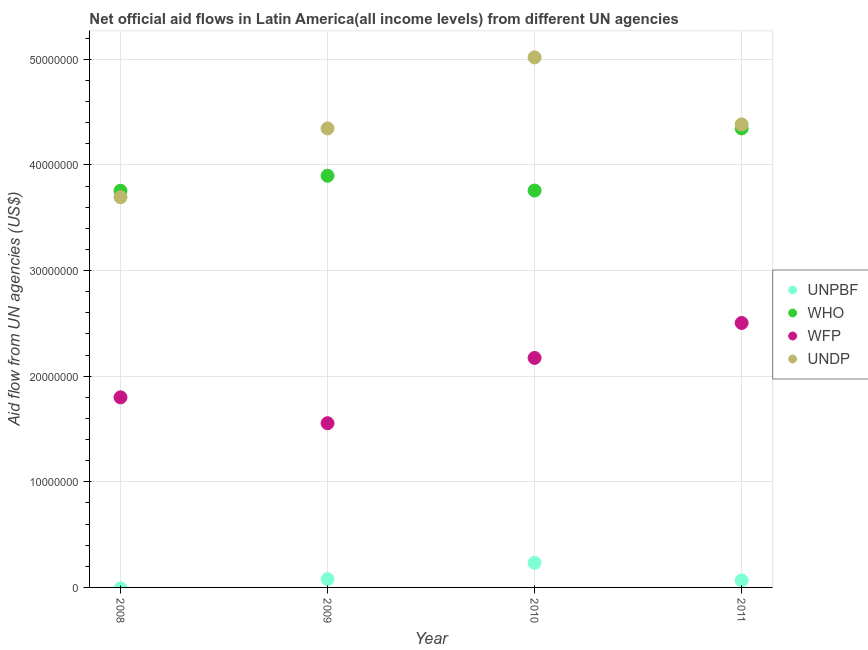How many different coloured dotlines are there?
Provide a succinct answer. 4. Is the number of dotlines equal to the number of legend labels?
Offer a very short reply. No. What is the amount of aid given by who in 2008?
Ensure brevity in your answer.  3.76e+07. Across all years, what is the maximum amount of aid given by unpbf?
Keep it short and to the point. 2.33e+06. Across all years, what is the minimum amount of aid given by undp?
Offer a terse response. 3.70e+07. What is the total amount of aid given by who in the graph?
Your response must be concise. 1.58e+08. What is the difference between the amount of aid given by undp in 2008 and that in 2009?
Provide a succinct answer. -6.51e+06. What is the difference between the amount of aid given by wfp in 2010 and the amount of aid given by undp in 2009?
Offer a terse response. -2.17e+07. What is the average amount of aid given by who per year?
Your response must be concise. 3.94e+07. In the year 2009, what is the difference between the amount of aid given by who and amount of aid given by wfp?
Provide a short and direct response. 2.34e+07. What is the ratio of the amount of aid given by who in 2008 to that in 2010?
Keep it short and to the point. 1. Is the difference between the amount of aid given by wfp in 2010 and 2011 greater than the difference between the amount of aid given by undp in 2010 and 2011?
Your answer should be compact. No. What is the difference between the highest and the second highest amount of aid given by wfp?
Your answer should be very brief. 3.31e+06. What is the difference between the highest and the lowest amount of aid given by undp?
Offer a very short reply. 1.32e+07. Is the sum of the amount of aid given by wfp in 2008 and 2010 greater than the maximum amount of aid given by who across all years?
Provide a succinct answer. No. Is it the case that in every year, the sum of the amount of aid given by unpbf and amount of aid given by who is greater than the sum of amount of aid given by undp and amount of aid given by wfp?
Offer a terse response. No. Is the amount of aid given by wfp strictly less than the amount of aid given by unpbf over the years?
Offer a terse response. No. How many dotlines are there?
Ensure brevity in your answer.  4. What is the difference between two consecutive major ticks on the Y-axis?
Your answer should be very brief. 1.00e+07. Does the graph contain any zero values?
Provide a short and direct response. Yes. Does the graph contain grids?
Ensure brevity in your answer.  Yes. How are the legend labels stacked?
Keep it short and to the point. Vertical. What is the title of the graph?
Provide a succinct answer. Net official aid flows in Latin America(all income levels) from different UN agencies. Does "Fiscal policy" appear as one of the legend labels in the graph?
Offer a very short reply. No. What is the label or title of the Y-axis?
Give a very brief answer. Aid flow from UN agencies (US$). What is the Aid flow from UN agencies (US$) in UNPBF in 2008?
Offer a terse response. 0. What is the Aid flow from UN agencies (US$) in WHO in 2008?
Your answer should be compact. 3.76e+07. What is the Aid flow from UN agencies (US$) in WFP in 2008?
Make the answer very short. 1.80e+07. What is the Aid flow from UN agencies (US$) of UNDP in 2008?
Offer a terse response. 3.70e+07. What is the Aid flow from UN agencies (US$) of UNPBF in 2009?
Your response must be concise. 7.90e+05. What is the Aid flow from UN agencies (US$) of WHO in 2009?
Provide a succinct answer. 3.90e+07. What is the Aid flow from UN agencies (US$) in WFP in 2009?
Keep it short and to the point. 1.56e+07. What is the Aid flow from UN agencies (US$) in UNDP in 2009?
Offer a terse response. 4.35e+07. What is the Aid flow from UN agencies (US$) of UNPBF in 2010?
Your response must be concise. 2.33e+06. What is the Aid flow from UN agencies (US$) of WHO in 2010?
Provide a succinct answer. 3.76e+07. What is the Aid flow from UN agencies (US$) in WFP in 2010?
Provide a short and direct response. 2.17e+07. What is the Aid flow from UN agencies (US$) in UNDP in 2010?
Your answer should be very brief. 5.02e+07. What is the Aid flow from UN agencies (US$) in UNPBF in 2011?
Give a very brief answer. 6.70e+05. What is the Aid flow from UN agencies (US$) of WHO in 2011?
Provide a short and direct response. 4.35e+07. What is the Aid flow from UN agencies (US$) in WFP in 2011?
Provide a succinct answer. 2.50e+07. What is the Aid flow from UN agencies (US$) of UNDP in 2011?
Give a very brief answer. 4.38e+07. Across all years, what is the maximum Aid flow from UN agencies (US$) in UNPBF?
Provide a succinct answer. 2.33e+06. Across all years, what is the maximum Aid flow from UN agencies (US$) in WHO?
Ensure brevity in your answer.  4.35e+07. Across all years, what is the maximum Aid flow from UN agencies (US$) of WFP?
Your answer should be compact. 2.50e+07. Across all years, what is the maximum Aid flow from UN agencies (US$) of UNDP?
Give a very brief answer. 5.02e+07. Across all years, what is the minimum Aid flow from UN agencies (US$) of UNPBF?
Offer a very short reply. 0. Across all years, what is the minimum Aid flow from UN agencies (US$) in WHO?
Offer a very short reply. 3.76e+07. Across all years, what is the minimum Aid flow from UN agencies (US$) in WFP?
Provide a short and direct response. 1.56e+07. Across all years, what is the minimum Aid flow from UN agencies (US$) in UNDP?
Keep it short and to the point. 3.70e+07. What is the total Aid flow from UN agencies (US$) of UNPBF in the graph?
Offer a terse response. 3.79e+06. What is the total Aid flow from UN agencies (US$) of WHO in the graph?
Ensure brevity in your answer.  1.58e+08. What is the total Aid flow from UN agencies (US$) in WFP in the graph?
Provide a short and direct response. 8.03e+07. What is the total Aid flow from UN agencies (US$) in UNDP in the graph?
Provide a succinct answer. 1.74e+08. What is the difference between the Aid flow from UN agencies (US$) in WHO in 2008 and that in 2009?
Provide a short and direct response. -1.42e+06. What is the difference between the Aid flow from UN agencies (US$) of WFP in 2008 and that in 2009?
Your answer should be compact. 2.45e+06. What is the difference between the Aid flow from UN agencies (US$) of UNDP in 2008 and that in 2009?
Give a very brief answer. -6.51e+06. What is the difference between the Aid flow from UN agencies (US$) of WFP in 2008 and that in 2010?
Ensure brevity in your answer.  -3.73e+06. What is the difference between the Aid flow from UN agencies (US$) in UNDP in 2008 and that in 2010?
Offer a very short reply. -1.32e+07. What is the difference between the Aid flow from UN agencies (US$) in WHO in 2008 and that in 2011?
Make the answer very short. -5.90e+06. What is the difference between the Aid flow from UN agencies (US$) in WFP in 2008 and that in 2011?
Keep it short and to the point. -7.04e+06. What is the difference between the Aid flow from UN agencies (US$) of UNDP in 2008 and that in 2011?
Provide a short and direct response. -6.89e+06. What is the difference between the Aid flow from UN agencies (US$) of UNPBF in 2009 and that in 2010?
Ensure brevity in your answer.  -1.54e+06. What is the difference between the Aid flow from UN agencies (US$) of WHO in 2009 and that in 2010?
Ensure brevity in your answer.  1.40e+06. What is the difference between the Aid flow from UN agencies (US$) in WFP in 2009 and that in 2010?
Keep it short and to the point. -6.18e+06. What is the difference between the Aid flow from UN agencies (US$) in UNDP in 2009 and that in 2010?
Your answer should be compact. -6.73e+06. What is the difference between the Aid flow from UN agencies (US$) of UNPBF in 2009 and that in 2011?
Ensure brevity in your answer.  1.20e+05. What is the difference between the Aid flow from UN agencies (US$) in WHO in 2009 and that in 2011?
Your answer should be compact. -4.48e+06. What is the difference between the Aid flow from UN agencies (US$) in WFP in 2009 and that in 2011?
Give a very brief answer. -9.49e+06. What is the difference between the Aid flow from UN agencies (US$) of UNDP in 2009 and that in 2011?
Offer a terse response. -3.80e+05. What is the difference between the Aid flow from UN agencies (US$) of UNPBF in 2010 and that in 2011?
Give a very brief answer. 1.66e+06. What is the difference between the Aid flow from UN agencies (US$) of WHO in 2010 and that in 2011?
Your answer should be compact. -5.88e+06. What is the difference between the Aid flow from UN agencies (US$) of WFP in 2010 and that in 2011?
Keep it short and to the point. -3.31e+06. What is the difference between the Aid flow from UN agencies (US$) in UNDP in 2010 and that in 2011?
Make the answer very short. 6.35e+06. What is the difference between the Aid flow from UN agencies (US$) of WHO in 2008 and the Aid flow from UN agencies (US$) of WFP in 2009?
Your answer should be very brief. 2.20e+07. What is the difference between the Aid flow from UN agencies (US$) of WHO in 2008 and the Aid flow from UN agencies (US$) of UNDP in 2009?
Give a very brief answer. -5.90e+06. What is the difference between the Aid flow from UN agencies (US$) of WFP in 2008 and the Aid flow from UN agencies (US$) of UNDP in 2009?
Provide a succinct answer. -2.55e+07. What is the difference between the Aid flow from UN agencies (US$) of WHO in 2008 and the Aid flow from UN agencies (US$) of WFP in 2010?
Ensure brevity in your answer.  1.58e+07. What is the difference between the Aid flow from UN agencies (US$) of WHO in 2008 and the Aid flow from UN agencies (US$) of UNDP in 2010?
Provide a succinct answer. -1.26e+07. What is the difference between the Aid flow from UN agencies (US$) of WFP in 2008 and the Aid flow from UN agencies (US$) of UNDP in 2010?
Provide a succinct answer. -3.22e+07. What is the difference between the Aid flow from UN agencies (US$) in WHO in 2008 and the Aid flow from UN agencies (US$) in WFP in 2011?
Your response must be concise. 1.25e+07. What is the difference between the Aid flow from UN agencies (US$) in WHO in 2008 and the Aid flow from UN agencies (US$) in UNDP in 2011?
Provide a short and direct response. -6.28e+06. What is the difference between the Aid flow from UN agencies (US$) of WFP in 2008 and the Aid flow from UN agencies (US$) of UNDP in 2011?
Keep it short and to the point. -2.58e+07. What is the difference between the Aid flow from UN agencies (US$) of UNPBF in 2009 and the Aid flow from UN agencies (US$) of WHO in 2010?
Ensure brevity in your answer.  -3.68e+07. What is the difference between the Aid flow from UN agencies (US$) in UNPBF in 2009 and the Aid flow from UN agencies (US$) in WFP in 2010?
Offer a very short reply. -2.09e+07. What is the difference between the Aid flow from UN agencies (US$) of UNPBF in 2009 and the Aid flow from UN agencies (US$) of UNDP in 2010?
Your answer should be very brief. -4.94e+07. What is the difference between the Aid flow from UN agencies (US$) of WHO in 2009 and the Aid flow from UN agencies (US$) of WFP in 2010?
Keep it short and to the point. 1.72e+07. What is the difference between the Aid flow from UN agencies (US$) in WHO in 2009 and the Aid flow from UN agencies (US$) in UNDP in 2010?
Provide a succinct answer. -1.12e+07. What is the difference between the Aid flow from UN agencies (US$) in WFP in 2009 and the Aid flow from UN agencies (US$) in UNDP in 2010?
Make the answer very short. -3.46e+07. What is the difference between the Aid flow from UN agencies (US$) in UNPBF in 2009 and the Aid flow from UN agencies (US$) in WHO in 2011?
Provide a short and direct response. -4.27e+07. What is the difference between the Aid flow from UN agencies (US$) in UNPBF in 2009 and the Aid flow from UN agencies (US$) in WFP in 2011?
Your response must be concise. -2.42e+07. What is the difference between the Aid flow from UN agencies (US$) in UNPBF in 2009 and the Aid flow from UN agencies (US$) in UNDP in 2011?
Give a very brief answer. -4.30e+07. What is the difference between the Aid flow from UN agencies (US$) in WHO in 2009 and the Aid flow from UN agencies (US$) in WFP in 2011?
Offer a very short reply. 1.39e+07. What is the difference between the Aid flow from UN agencies (US$) in WHO in 2009 and the Aid flow from UN agencies (US$) in UNDP in 2011?
Offer a very short reply. -4.86e+06. What is the difference between the Aid flow from UN agencies (US$) in WFP in 2009 and the Aid flow from UN agencies (US$) in UNDP in 2011?
Provide a short and direct response. -2.83e+07. What is the difference between the Aid flow from UN agencies (US$) of UNPBF in 2010 and the Aid flow from UN agencies (US$) of WHO in 2011?
Your response must be concise. -4.11e+07. What is the difference between the Aid flow from UN agencies (US$) of UNPBF in 2010 and the Aid flow from UN agencies (US$) of WFP in 2011?
Your answer should be very brief. -2.27e+07. What is the difference between the Aid flow from UN agencies (US$) in UNPBF in 2010 and the Aid flow from UN agencies (US$) in UNDP in 2011?
Provide a succinct answer. -4.15e+07. What is the difference between the Aid flow from UN agencies (US$) in WHO in 2010 and the Aid flow from UN agencies (US$) in WFP in 2011?
Give a very brief answer. 1.25e+07. What is the difference between the Aid flow from UN agencies (US$) in WHO in 2010 and the Aid flow from UN agencies (US$) in UNDP in 2011?
Ensure brevity in your answer.  -6.26e+06. What is the difference between the Aid flow from UN agencies (US$) in WFP in 2010 and the Aid flow from UN agencies (US$) in UNDP in 2011?
Your answer should be compact. -2.21e+07. What is the average Aid flow from UN agencies (US$) of UNPBF per year?
Provide a short and direct response. 9.48e+05. What is the average Aid flow from UN agencies (US$) in WHO per year?
Your answer should be compact. 3.94e+07. What is the average Aid flow from UN agencies (US$) in WFP per year?
Keep it short and to the point. 2.01e+07. What is the average Aid flow from UN agencies (US$) of UNDP per year?
Ensure brevity in your answer.  4.36e+07. In the year 2008, what is the difference between the Aid flow from UN agencies (US$) in WHO and Aid flow from UN agencies (US$) in WFP?
Keep it short and to the point. 1.96e+07. In the year 2008, what is the difference between the Aid flow from UN agencies (US$) in WHO and Aid flow from UN agencies (US$) in UNDP?
Offer a very short reply. 6.10e+05. In the year 2008, what is the difference between the Aid flow from UN agencies (US$) in WFP and Aid flow from UN agencies (US$) in UNDP?
Give a very brief answer. -1.90e+07. In the year 2009, what is the difference between the Aid flow from UN agencies (US$) of UNPBF and Aid flow from UN agencies (US$) of WHO?
Offer a very short reply. -3.82e+07. In the year 2009, what is the difference between the Aid flow from UN agencies (US$) of UNPBF and Aid flow from UN agencies (US$) of WFP?
Make the answer very short. -1.48e+07. In the year 2009, what is the difference between the Aid flow from UN agencies (US$) of UNPBF and Aid flow from UN agencies (US$) of UNDP?
Your answer should be very brief. -4.27e+07. In the year 2009, what is the difference between the Aid flow from UN agencies (US$) in WHO and Aid flow from UN agencies (US$) in WFP?
Offer a terse response. 2.34e+07. In the year 2009, what is the difference between the Aid flow from UN agencies (US$) of WHO and Aid flow from UN agencies (US$) of UNDP?
Your answer should be compact. -4.48e+06. In the year 2009, what is the difference between the Aid flow from UN agencies (US$) in WFP and Aid flow from UN agencies (US$) in UNDP?
Your answer should be very brief. -2.79e+07. In the year 2010, what is the difference between the Aid flow from UN agencies (US$) in UNPBF and Aid flow from UN agencies (US$) in WHO?
Provide a short and direct response. -3.52e+07. In the year 2010, what is the difference between the Aid flow from UN agencies (US$) of UNPBF and Aid flow from UN agencies (US$) of WFP?
Provide a short and direct response. -1.94e+07. In the year 2010, what is the difference between the Aid flow from UN agencies (US$) in UNPBF and Aid flow from UN agencies (US$) in UNDP?
Offer a terse response. -4.79e+07. In the year 2010, what is the difference between the Aid flow from UN agencies (US$) of WHO and Aid flow from UN agencies (US$) of WFP?
Offer a terse response. 1.58e+07. In the year 2010, what is the difference between the Aid flow from UN agencies (US$) in WHO and Aid flow from UN agencies (US$) in UNDP?
Your answer should be compact. -1.26e+07. In the year 2010, what is the difference between the Aid flow from UN agencies (US$) of WFP and Aid flow from UN agencies (US$) of UNDP?
Offer a very short reply. -2.85e+07. In the year 2011, what is the difference between the Aid flow from UN agencies (US$) of UNPBF and Aid flow from UN agencies (US$) of WHO?
Your answer should be very brief. -4.28e+07. In the year 2011, what is the difference between the Aid flow from UN agencies (US$) of UNPBF and Aid flow from UN agencies (US$) of WFP?
Your response must be concise. -2.44e+07. In the year 2011, what is the difference between the Aid flow from UN agencies (US$) in UNPBF and Aid flow from UN agencies (US$) in UNDP?
Make the answer very short. -4.32e+07. In the year 2011, what is the difference between the Aid flow from UN agencies (US$) in WHO and Aid flow from UN agencies (US$) in WFP?
Provide a short and direct response. 1.84e+07. In the year 2011, what is the difference between the Aid flow from UN agencies (US$) in WHO and Aid flow from UN agencies (US$) in UNDP?
Your response must be concise. -3.80e+05. In the year 2011, what is the difference between the Aid flow from UN agencies (US$) in WFP and Aid flow from UN agencies (US$) in UNDP?
Provide a short and direct response. -1.88e+07. What is the ratio of the Aid flow from UN agencies (US$) in WHO in 2008 to that in 2009?
Ensure brevity in your answer.  0.96. What is the ratio of the Aid flow from UN agencies (US$) of WFP in 2008 to that in 2009?
Provide a short and direct response. 1.16. What is the ratio of the Aid flow from UN agencies (US$) in UNDP in 2008 to that in 2009?
Provide a short and direct response. 0.85. What is the ratio of the Aid flow from UN agencies (US$) of WFP in 2008 to that in 2010?
Keep it short and to the point. 0.83. What is the ratio of the Aid flow from UN agencies (US$) in UNDP in 2008 to that in 2010?
Ensure brevity in your answer.  0.74. What is the ratio of the Aid flow from UN agencies (US$) of WHO in 2008 to that in 2011?
Make the answer very short. 0.86. What is the ratio of the Aid flow from UN agencies (US$) in WFP in 2008 to that in 2011?
Your response must be concise. 0.72. What is the ratio of the Aid flow from UN agencies (US$) in UNDP in 2008 to that in 2011?
Keep it short and to the point. 0.84. What is the ratio of the Aid flow from UN agencies (US$) in UNPBF in 2009 to that in 2010?
Your answer should be compact. 0.34. What is the ratio of the Aid flow from UN agencies (US$) in WHO in 2009 to that in 2010?
Keep it short and to the point. 1.04. What is the ratio of the Aid flow from UN agencies (US$) of WFP in 2009 to that in 2010?
Ensure brevity in your answer.  0.72. What is the ratio of the Aid flow from UN agencies (US$) of UNDP in 2009 to that in 2010?
Give a very brief answer. 0.87. What is the ratio of the Aid flow from UN agencies (US$) of UNPBF in 2009 to that in 2011?
Provide a succinct answer. 1.18. What is the ratio of the Aid flow from UN agencies (US$) in WHO in 2009 to that in 2011?
Provide a short and direct response. 0.9. What is the ratio of the Aid flow from UN agencies (US$) of WFP in 2009 to that in 2011?
Your response must be concise. 0.62. What is the ratio of the Aid flow from UN agencies (US$) in UNDP in 2009 to that in 2011?
Ensure brevity in your answer.  0.99. What is the ratio of the Aid flow from UN agencies (US$) in UNPBF in 2010 to that in 2011?
Your answer should be compact. 3.48. What is the ratio of the Aid flow from UN agencies (US$) in WHO in 2010 to that in 2011?
Your answer should be very brief. 0.86. What is the ratio of the Aid flow from UN agencies (US$) in WFP in 2010 to that in 2011?
Offer a terse response. 0.87. What is the ratio of the Aid flow from UN agencies (US$) of UNDP in 2010 to that in 2011?
Offer a terse response. 1.14. What is the difference between the highest and the second highest Aid flow from UN agencies (US$) in UNPBF?
Provide a short and direct response. 1.54e+06. What is the difference between the highest and the second highest Aid flow from UN agencies (US$) of WHO?
Provide a short and direct response. 4.48e+06. What is the difference between the highest and the second highest Aid flow from UN agencies (US$) of WFP?
Your answer should be very brief. 3.31e+06. What is the difference between the highest and the second highest Aid flow from UN agencies (US$) in UNDP?
Make the answer very short. 6.35e+06. What is the difference between the highest and the lowest Aid flow from UN agencies (US$) in UNPBF?
Keep it short and to the point. 2.33e+06. What is the difference between the highest and the lowest Aid flow from UN agencies (US$) of WHO?
Make the answer very short. 5.90e+06. What is the difference between the highest and the lowest Aid flow from UN agencies (US$) in WFP?
Provide a short and direct response. 9.49e+06. What is the difference between the highest and the lowest Aid flow from UN agencies (US$) of UNDP?
Your response must be concise. 1.32e+07. 